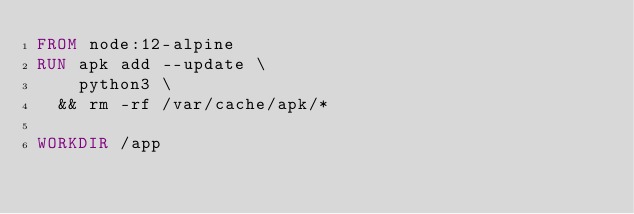Convert code to text. <code><loc_0><loc_0><loc_500><loc_500><_Dockerfile_>FROM node:12-alpine
RUN apk add --update \
    python3 \
  && rm -rf /var/cache/apk/*

WORKDIR /app</code> 